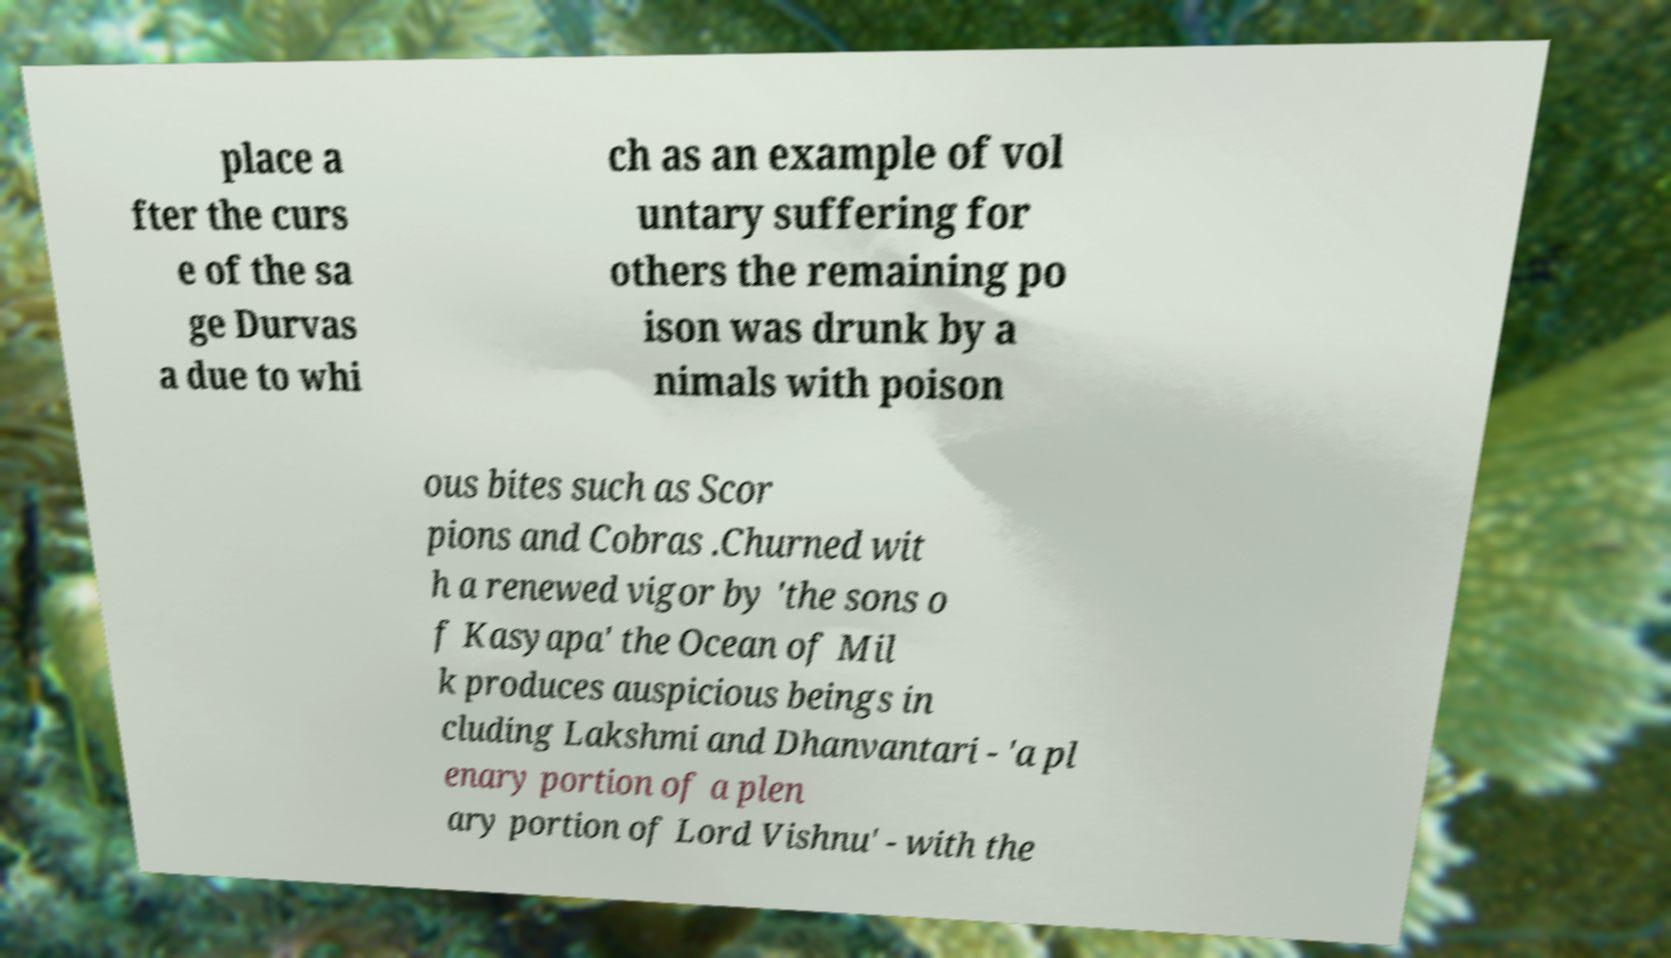What messages or text are displayed in this image? I need them in a readable, typed format. place a fter the curs e of the sa ge Durvas a due to whi ch as an example of vol untary suffering for others the remaining po ison was drunk by a nimals with poison ous bites such as Scor pions and Cobras .Churned wit h a renewed vigor by 'the sons o f Kasyapa' the Ocean of Mil k produces auspicious beings in cluding Lakshmi and Dhanvantari - 'a pl enary portion of a plen ary portion of Lord Vishnu' - with the 